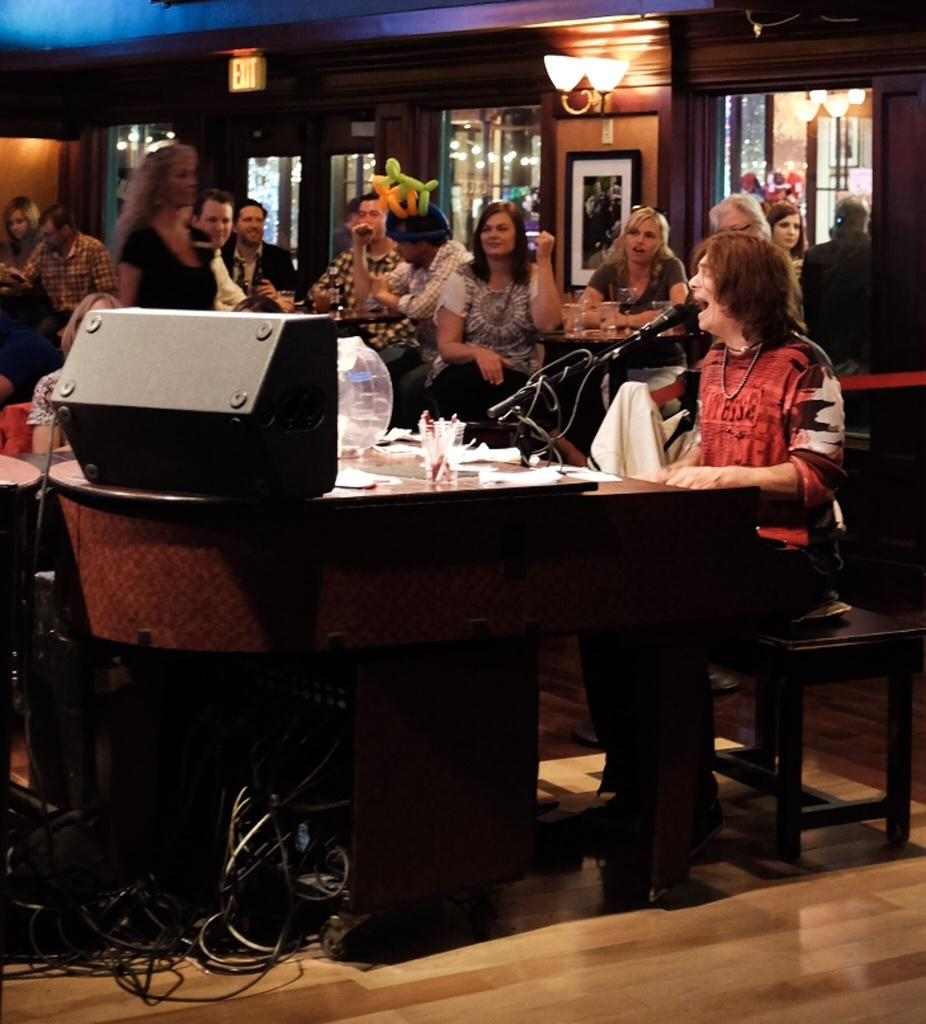How many people are present in the image? There are multiple people in the image. What is the woman in the image doing? One woman is sitting in front of a mic. What can be seen in the background of the image? There is a frame and a light on the wall in the background. Can you tell me how many seeds are on the flowers in the image? There are no flowers or seeds present in the image. What type of stranger is standing next to the woman in the image? There is no stranger present in the image; only multiple people are visible. 